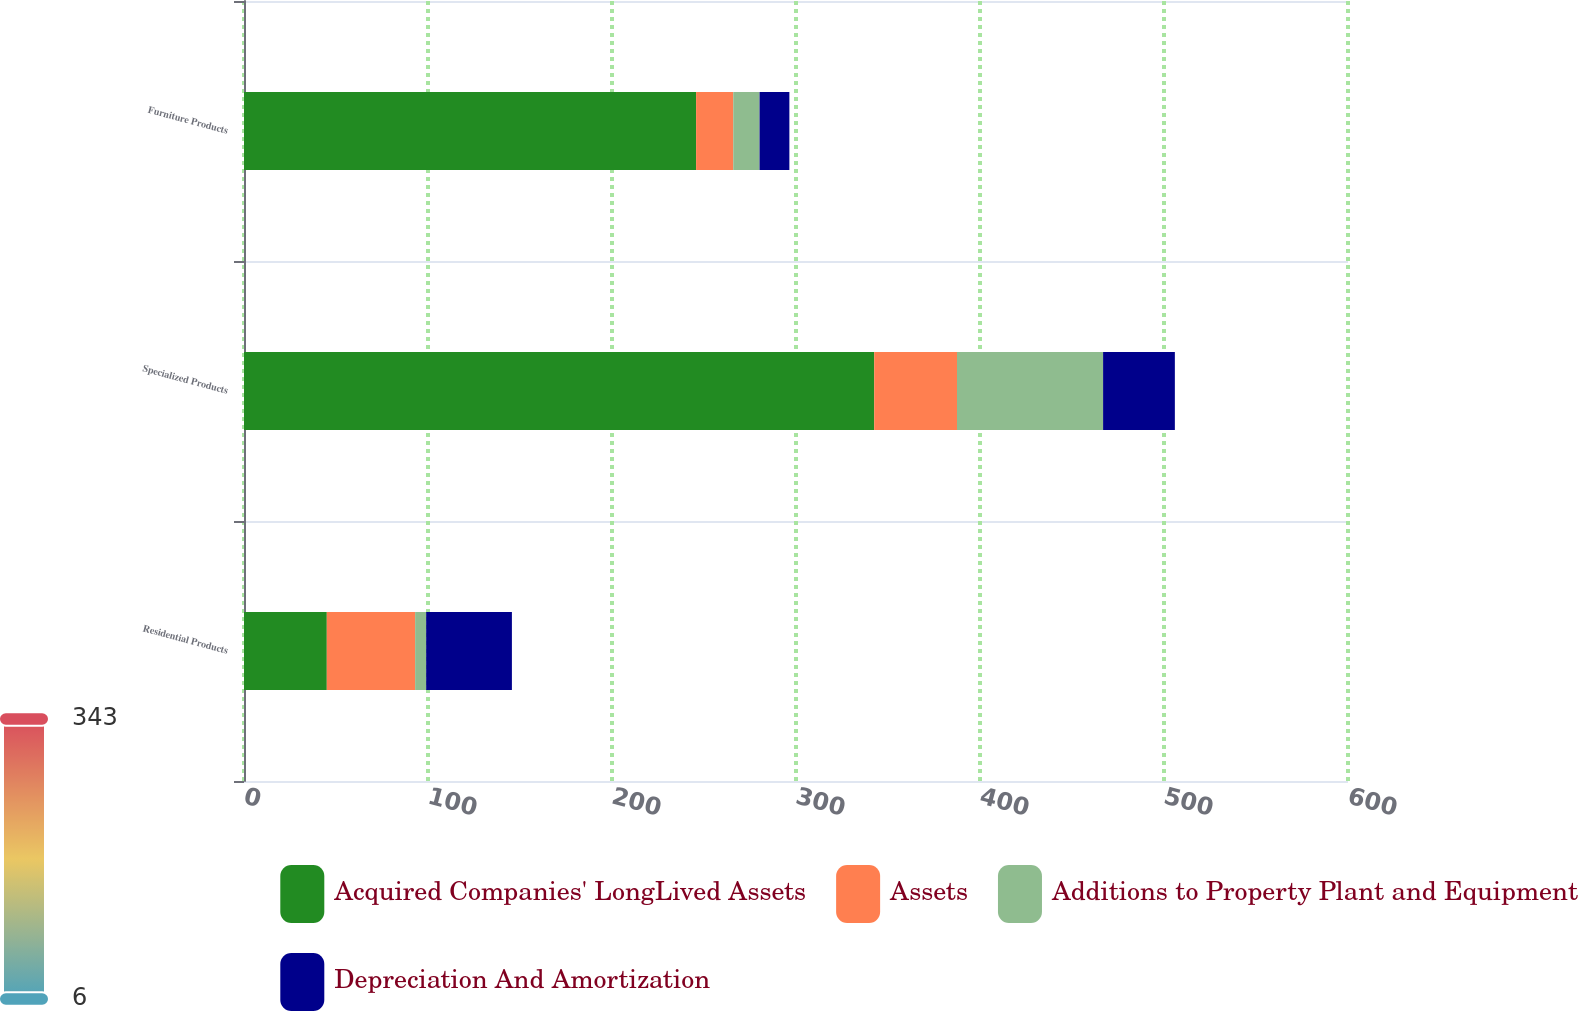<chart> <loc_0><loc_0><loc_500><loc_500><stacked_bar_chart><ecel><fcel>Residential Products<fcel>Specialized Products<fcel>Furniture Products<nl><fcel>Acquired Companies' LongLived Assets<fcel>45<fcel>342.5<fcel>245.7<nl><fcel>Assets<fcel>48<fcel>45<fcel>20.2<nl><fcel>Additions to Property Plant and Equipment<fcel>6<fcel>79.4<fcel>14.3<nl><fcel>Depreciation And Amortization<fcel>46.6<fcel>39<fcel>16.2<nl></chart> 